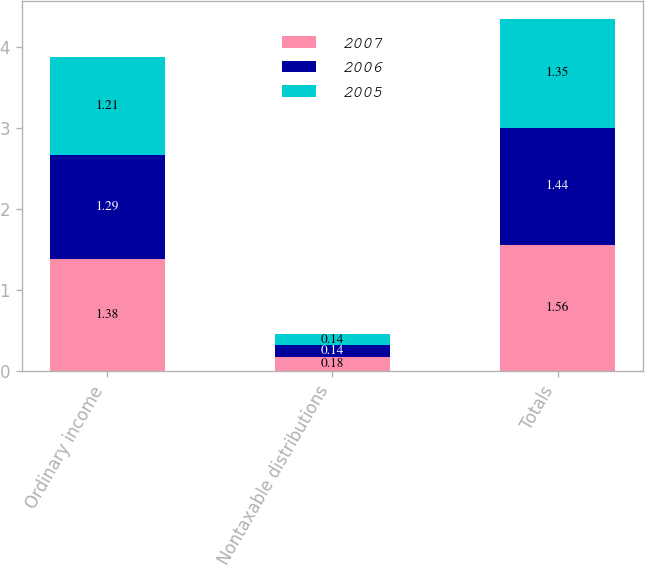Convert chart. <chart><loc_0><loc_0><loc_500><loc_500><stacked_bar_chart><ecel><fcel>Ordinary income<fcel>Nontaxable distributions<fcel>Totals<nl><fcel>2007<fcel>1.38<fcel>0.18<fcel>1.56<nl><fcel>2006<fcel>1.29<fcel>0.14<fcel>1.44<nl><fcel>2005<fcel>1.21<fcel>0.14<fcel>1.35<nl></chart> 